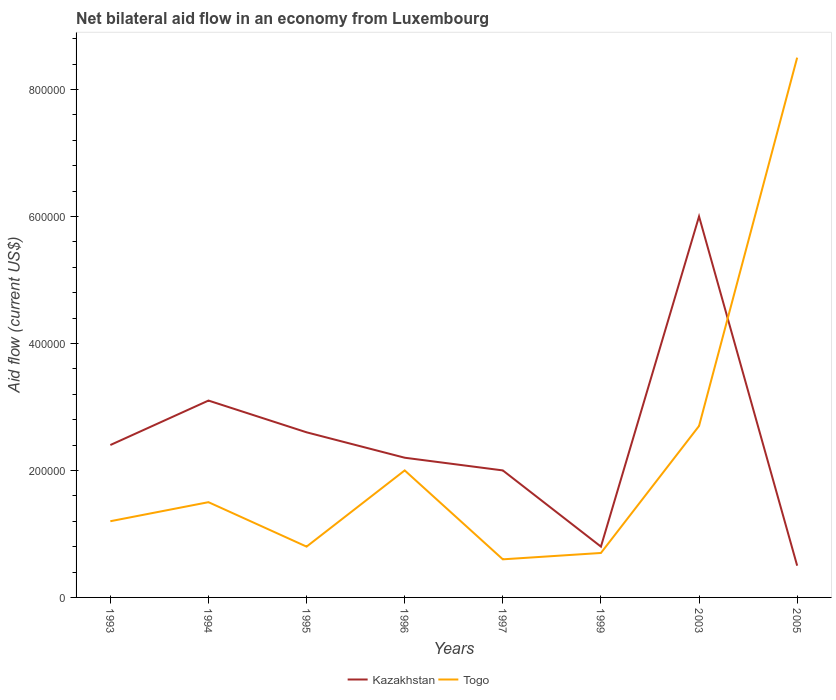Does the line corresponding to Togo intersect with the line corresponding to Kazakhstan?
Your answer should be very brief. Yes. Is the number of lines equal to the number of legend labels?
Give a very brief answer. Yes. Across all years, what is the maximum net bilateral aid flow in Kazakhstan?
Offer a terse response. 5.00e+04. In which year was the net bilateral aid flow in Togo maximum?
Offer a terse response. 1997. What is the difference between the highest and the second highest net bilateral aid flow in Togo?
Ensure brevity in your answer.  7.90e+05. What is the difference between the highest and the lowest net bilateral aid flow in Kazakhstan?
Provide a succinct answer. 3. What is the difference between two consecutive major ticks on the Y-axis?
Provide a succinct answer. 2.00e+05. Does the graph contain any zero values?
Your response must be concise. No. How are the legend labels stacked?
Ensure brevity in your answer.  Horizontal. What is the title of the graph?
Ensure brevity in your answer.  Net bilateral aid flow in an economy from Luxembourg. Does "Middle income" appear as one of the legend labels in the graph?
Your answer should be compact. No. What is the label or title of the X-axis?
Offer a terse response. Years. What is the label or title of the Y-axis?
Provide a short and direct response. Aid flow (current US$). What is the Aid flow (current US$) in Kazakhstan in 1993?
Your response must be concise. 2.40e+05. What is the Aid flow (current US$) of Kazakhstan in 1994?
Your answer should be compact. 3.10e+05. What is the Aid flow (current US$) of Kazakhstan in 1995?
Make the answer very short. 2.60e+05. What is the Aid flow (current US$) of Kazakhstan in 1996?
Make the answer very short. 2.20e+05. What is the Aid flow (current US$) in Kazakhstan in 1997?
Keep it short and to the point. 2.00e+05. What is the Aid flow (current US$) in Togo in 2003?
Offer a terse response. 2.70e+05. What is the Aid flow (current US$) of Togo in 2005?
Give a very brief answer. 8.50e+05. Across all years, what is the maximum Aid flow (current US$) of Kazakhstan?
Give a very brief answer. 6.00e+05. Across all years, what is the maximum Aid flow (current US$) in Togo?
Provide a succinct answer. 8.50e+05. Across all years, what is the minimum Aid flow (current US$) of Kazakhstan?
Offer a terse response. 5.00e+04. Across all years, what is the minimum Aid flow (current US$) in Togo?
Give a very brief answer. 6.00e+04. What is the total Aid flow (current US$) in Kazakhstan in the graph?
Your answer should be very brief. 1.96e+06. What is the total Aid flow (current US$) in Togo in the graph?
Give a very brief answer. 1.80e+06. What is the difference between the Aid flow (current US$) of Kazakhstan in 1993 and that in 1994?
Give a very brief answer. -7.00e+04. What is the difference between the Aid flow (current US$) of Togo in 1993 and that in 1997?
Provide a short and direct response. 6.00e+04. What is the difference between the Aid flow (current US$) of Kazakhstan in 1993 and that in 1999?
Your answer should be very brief. 1.60e+05. What is the difference between the Aid flow (current US$) in Togo in 1993 and that in 1999?
Your answer should be very brief. 5.00e+04. What is the difference between the Aid flow (current US$) of Kazakhstan in 1993 and that in 2003?
Make the answer very short. -3.60e+05. What is the difference between the Aid flow (current US$) in Togo in 1993 and that in 2003?
Your answer should be compact. -1.50e+05. What is the difference between the Aid flow (current US$) of Togo in 1993 and that in 2005?
Your response must be concise. -7.30e+05. What is the difference between the Aid flow (current US$) in Togo in 1994 and that in 1995?
Offer a very short reply. 7.00e+04. What is the difference between the Aid flow (current US$) in Kazakhstan in 1994 and that in 1997?
Offer a very short reply. 1.10e+05. What is the difference between the Aid flow (current US$) of Kazakhstan in 1994 and that in 1999?
Ensure brevity in your answer.  2.30e+05. What is the difference between the Aid flow (current US$) of Togo in 1994 and that in 2005?
Your response must be concise. -7.00e+05. What is the difference between the Aid flow (current US$) in Togo in 1995 and that in 1996?
Ensure brevity in your answer.  -1.20e+05. What is the difference between the Aid flow (current US$) in Kazakhstan in 1995 and that in 1997?
Your answer should be very brief. 6.00e+04. What is the difference between the Aid flow (current US$) of Togo in 1995 and that in 1997?
Your answer should be compact. 2.00e+04. What is the difference between the Aid flow (current US$) in Kazakhstan in 1995 and that in 2003?
Offer a very short reply. -3.40e+05. What is the difference between the Aid flow (current US$) of Togo in 1995 and that in 2003?
Your response must be concise. -1.90e+05. What is the difference between the Aid flow (current US$) of Kazakhstan in 1995 and that in 2005?
Your answer should be very brief. 2.10e+05. What is the difference between the Aid flow (current US$) in Togo in 1995 and that in 2005?
Offer a terse response. -7.70e+05. What is the difference between the Aid flow (current US$) in Kazakhstan in 1996 and that in 1997?
Ensure brevity in your answer.  2.00e+04. What is the difference between the Aid flow (current US$) of Togo in 1996 and that in 1997?
Ensure brevity in your answer.  1.40e+05. What is the difference between the Aid flow (current US$) of Kazakhstan in 1996 and that in 1999?
Offer a terse response. 1.40e+05. What is the difference between the Aid flow (current US$) of Togo in 1996 and that in 1999?
Offer a very short reply. 1.30e+05. What is the difference between the Aid flow (current US$) in Kazakhstan in 1996 and that in 2003?
Your answer should be very brief. -3.80e+05. What is the difference between the Aid flow (current US$) of Togo in 1996 and that in 2005?
Your answer should be compact. -6.50e+05. What is the difference between the Aid flow (current US$) of Kazakhstan in 1997 and that in 1999?
Your response must be concise. 1.20e+05. What is the difference between the Aid flow (current US$) in Togo in 1997 and that in 1999?
Make the answer very short. -10000. What is the difference between the Aid flow (current US$) of Kazakhstan in 1997 and that in 2003?
Make the answer very short. -4.00e+05. What is the difference between the Aid flow (current US$) in Togo in 1997 and that in 2005?
Ensure brevity in your answer.  -7.90e+05. What is the difference between the Aid flow (current US$) in Kazakhstan in 1999 and that in 2003?
Provide a succinct answer. -5.20e+05. What is the difference between the Aid flow (current US$) in Kazakhstan in 1999 and that in 2005?
Keep it short and to the point. 3.00e+04. What is the difference between the Aid flow (current US$) in Togo in 1999 and that in 2005?
Offer a very short reply. -7.80e+05. What is the difference between the Aid flow (current US$) of Kazakhstan in 2003 and that in 2005?
Your answer should be very brief. 5.50e+05. What is the difference between the Aid flow (current US$) in Togo in 2003 and that in 2005?
Offer a terse response. -5.80e+05. What is the difference between the Aid flow (current US$) of Kazakhstan in 1993 and the Aid flow (current US$) of Togo in 1994?
Provide a succinct answer. 9.00e+04. What is the difference between the Aid flow (current US$) in Kazakhstan in 1993 and the Aid flow (current US$) in Togo in 1995?
Make the answer very short. 1.60e+05. What is the difference between the Aid flow (current US$) of Kazakhstan in 1993 and the Aid flow (current US$) of Togo in 1996?
Your answer should be compact. 4.00e+04. What is the difference between the Aid flow (current US$) in Kazakhstan in 1993 and the Aid flow (current US$) in Togo in 1999?
Your response must be concise. 1.70e+05. What is the difference between the Aid flow (current US$) of Kazakhstan in 1993 and the Aid flow (current US$) of Togo in 2003?
Provide a succinct answer. -3.00e+04. What is the difference between the Aid flow (current US$) in Kazakhstan in 1993 and the Aid flow (current US$) in Togo in 2005?
Provide a succinct answer. -6.10e+05. What is the difference between the Aid flow (current US$) in Kazakhstan in 1994 and the Aid flow (current US$) in Togo in 1995?
Your answer should be compact. 2.30e+05. What is the difference between the Aid flow (current US$) in Kazakhstan in 1994 and the Aid flow (current US$) in Togo in 1999?
Your answer should be compact. 2.40e+05. What is the difference between the Aid flow (current US$) in Kazakhstan in 1994 and the Aid flow (current US$) in Togo in 2005?
Give a very brief answer. -5.40e+05. What is the difference between the Aid flow (current US$) of Kazakhstan in 1995 and the Aid flow (current US$) of Togo in 1996?
Provide a succinct answer. 6.00e+04. What is the difference between the Aid flow (current US$) of Kazakhstan in 1995 and the Aid flow (current US$) of Togo in 1997?
Offer a terse response. 2.00e+05. What is the difference between the Aid flow (current US$) of Kazakhstan in 1995 and the Aid flow (current US$) of Togo in 1999?
Keep it short and to the point. 1.90e+05. What is the difference between the Aid flow (current US$) in Kazakhstan in 1995 and the Aid flow (current US$) in Togo in 2005?
Keep it short and to the point. -5.90e+05. What is the difference between the Aid flow (current US$) of Kazakhstan in 1996 and the Aid flow (current US$) of Togo in 2005?
Your answer should be very brief. -6.30e+05. What is the difference between the Aid flow (current US$) in Kazakhstan in 1997 and the Aid flow (current US$) in Togo in 1999?
Offer a very short reply. 1.30e+05. What is the difference between the Aid flow (current US$) of Kazakhstan in 1997 and the Aid flow (current US$) of Togo in 2003?
Offer a terse response. -7.00e+04. What is the difference between the Aid flow (current US$) of Kazakhstan in 1997 and the Aid flow (current US$) of Togo in 2005?
Offer a very short reply. -6.50e+05. What is the difference between the Aid flow (current US$) of Kazakhstan in 1999 and the Aid flow (current US$) of Togo in 2005?
Provide a short and direct response. -7.70e+05. What is the difference between the Aid flow (current US$) in Kazakhstan in 2003 and the Aid flow (current US$) in Togo in 2005?
Offer a very short reply. -2.50e+05. What is the average Aid flow (current US$) of Kazakhstan per year?
Make the answer very short. 2.45e+05. What is the average Aid flow (current US$) in Togo per year?
Give a very brief answer. 2.25e+05. In the year 2003, what is the difference between the Aid flow (current US$) of Kazakhstan and Aid flow (current US$) of Togo?
Your answer should be very brief. 3.30e+05. In the year 2005, what is the difference between the Aid flow (current US$) in Kazakhstan and Aid flow (current US$) in Togo?
Offer a terse response. -8.00e+05. What is the ratio of the Aid flow (current US$) in Kazakhstan in 1993 to that in 1994?
Keep it short and to the point. 0.77. What is the ratio of the Aid flow (current US$) in Togo in 1993 to that in 1994?
Give a very brief answer. 0.8. What is the ratio of the Aid flow (current US$) in Kazakhstan in 1993 to that in 1995?
Give a very brief answer. 0.92. What is the ratio of the Aid flow (current US$) in Togo in 1993 to that in 1996?
Your answer should be very brief. 0.6. What is the ratio of the Aid flow (current US$) of Kazakhstan in 1993 to that in 1997?
Offer a very short reply. 1.2. What is the ratio of the Aid flow (current US$) of Togo in 1993 to that in 1999?
Provide a succinct answer. 1.71. What is the ratio of the Aid flow (current US$) in Kazakhstan in 1993 to that in 2003?
Provide a short and direct response. 0.4. What is the ratio of the Aid flow (current US$) in Togo in 1993 to that in 2003?
Your answer should be compact. 0.44. What is the ratio of the Aid flow (current US$) in Kazakhstan in 1993 to that in 2005?
Provide a succinct answer. 4.8. What is the ratio of the Aid flow (current US$) in Togo in 1993 to that in 2005?
Your answer should be very brief. 0.14. What is the ratio of the Aid flow (current US$) in Kazakhstan in 1994 to that in 1995?
Your answer should be compact. 1.19. What is the ratio of the Aid flow (current US$) of Togo in 1994 to that in 1995?
Offer a terse response. 1.88. What is the ratio of the Aid flow (current US$) in Kazakhstan in 1994 to that in 1996?
Make the answer very short. 1.41. What is the ratio of the Aid flow (current US$) of Kazakhstan in 1994 to that in 1997?
Keep it short and to the point. 1.55. What is the ratio of the Aid flow (current US$) of Togo in 1994 to that in 1997?
Your answer should be very brief. 2.5. What is the ratio of the Aid flow (current US$) of Kazakhstan in 1994 to that in 1999?
Offer a terse response. 3.88. What is the ratio of the Aid flow (current US$) of Togo in 1994 to that in 1999?
Your answer should be compact. 2.14. What is the ratio of the Aid flow (current US$) of Kazakhstan in 1994 to that in 2003?
Your answer should be very brief. 0.52. What is the ratio of the Aid flow (current US$) in Togo in 1994 to that in 2003?
Give a very brief answer. 0.56. What is the ratio of the Aid flow (current US$) in Kazakhstan in 1994 to that in 2005?
Make the answer very short. 6.2. What is the ratio of the Aid flow (current US$) of Togo in 1994 to that in 2005?
Ensure brevity in your answer.  0.18. What is the ratio of the Aid flow (current US$) in Kazakhstan in 1995 to that in 1996?
Keep it short and to the point. 1.18. What is the ratio of the Aid flow (current US$) in Togo in 1995 to that in 1997?
Your response must be concise. 1.33. What is the ratio of the Aid flow (current US$) in Togo in 1995 to that in 1999?
Keep it short and to the point. 1.14. What is the ratio of the Aid flow (current US$) in Kazakhstan in 1995 to that in 2003?
Make the answer very short. 0.43. What is the ratio of the Aid flow (current US$) of Togo in 1995 to that in 2003?
Give a very brief answer. 0.3. What is the ratio of the Aid flow (current US$) of Togo in 1995 to that in 2005?
Keep it short and to the point. 0.09. What is the ratio of the Aid flow (current US$) of Kazakhstan in 1996 to that in 1997?
Provide a succinct answer. 1.1. What is the ratio of the Aid flow (current US$) of Kazakhstan in 1996 to that in 1999?
Ensure brevity in your answer.  2.75. What is the ratio of the Aid flow (current US$) of Togo in 1996 to that in 1999?
Your answer should be very brief. 2.86. What is the ratio of the Aid flow (current US$) of Kazakhstan in 1996 to that in 2003?
Keep it short and to the point. 0.37. What is the ratio of the Aid flow (current US$) in Togo in 1996 to that in 2003?
Ensure brevity in your answer.  0.74. What is the ratio of the Aid flow (current US$) of Kazakhstan in 1996 to that in 2005?
Ensure brevity in your answer.  4.4. What is the ratio of the Aid flow (current US$) of Togo in 1996 to that in 2005?
Make the answer very short. 0.24. What is the ratio of the Aid flow (current US$) of Kazakhstan in 1997 to that in 1999?
Ensure brevity in your answer.  2.5. What is the ratio of the Aid flow (current US$) of Togo in 1997 to that in 1999?
Your response must be concise. 0.86. What is the ratio of the Aid flow (current US$) in Kazakhstan in 1997 to that in 2003?
Offer a terse response. 0.33. What is the ratio of the Aid flow (current US$) in Togo in 1997 to that in 2003?
Provide a short and direct response. 0.22. What is the ratio of the Aid flow (current US$) in Togo in 1997 to that in 2005?
Offer a very short reply. 0.07. What is the ratio of the Aid flow (current US$) of Kazakhstan in 1999 to that in 2003?
Offer a terse response. 0.13. What is the ratio of the Aid flow (current US$) of Togo in 1999 to that in 2003?
Ensure brevity in your answer.  0.26. What is the ratio of the Aid flow (current US$) in Togo in 1999 to that in 2005?
Your answer should be very brief. 0.08. What is the ratio of the Aid flow (current US$) of Kazakhstan in 2003 to that in 2005?
Ensure brevity in your answer.  12. What is the ratio of the Aid flow (current US$) in Togo in 2003 to that in 2005?
Your answer should be compact. 0.32. What is the difference between the highest and the second highest Aid flow (current US$) in Kazakhstan?
Your answer should be compact. 2.90e+05. What is the difference between the highest and the second highest Aid flow (current US$) of Togo?
Keep it short and to the point. 5.80e+05. What is the difference between the highest and the lowest Aid flow (current US$) of Kazakhstan?
Provide a short and direct response. 5.50e+05. What is the difference between the highest and the lowest Aid flow (current US$) in Togo?
Give a very brief answer. 7.90e+05. 